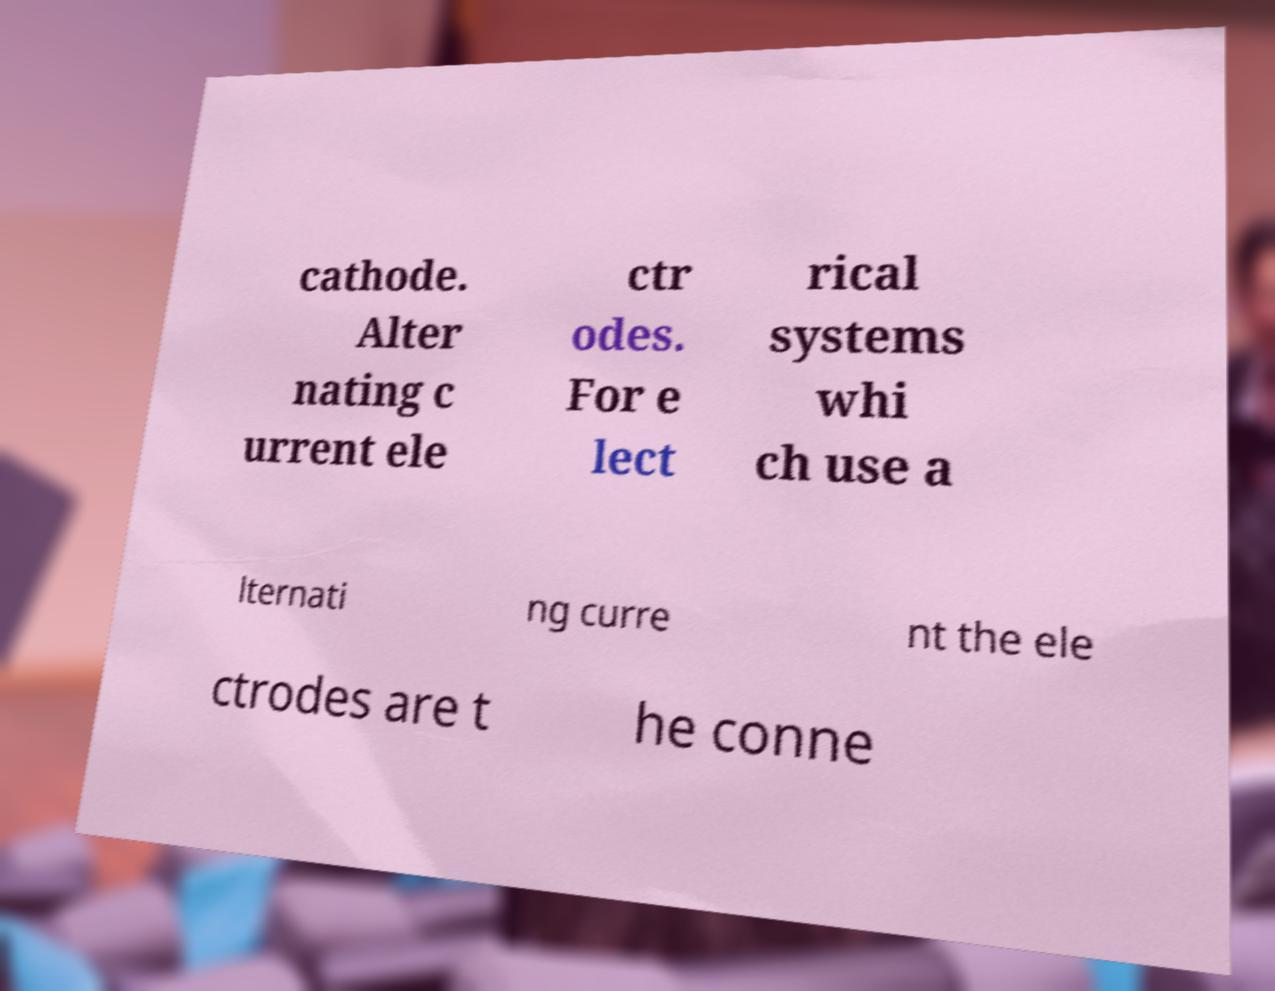I need the written content from this picture converted into text. Can you do that? cathode. Alter nating c urrent ele ctr odes. For e lect rical systems whi ch use a lternati ng curre nt the ele ctrodes are t he conne 